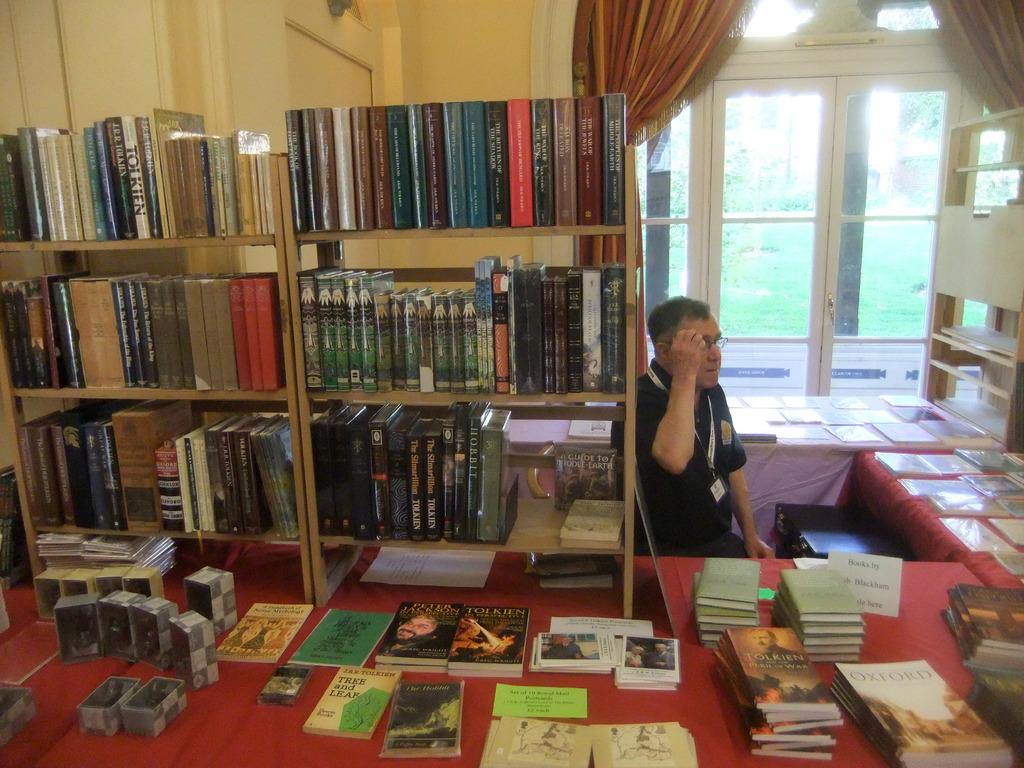<image>
Offer a succinct explanation of the picture presented. A man is sitting in front of a bookshelf, with a table beside him that has several books laid out, with the name Tolkien on the covers. 